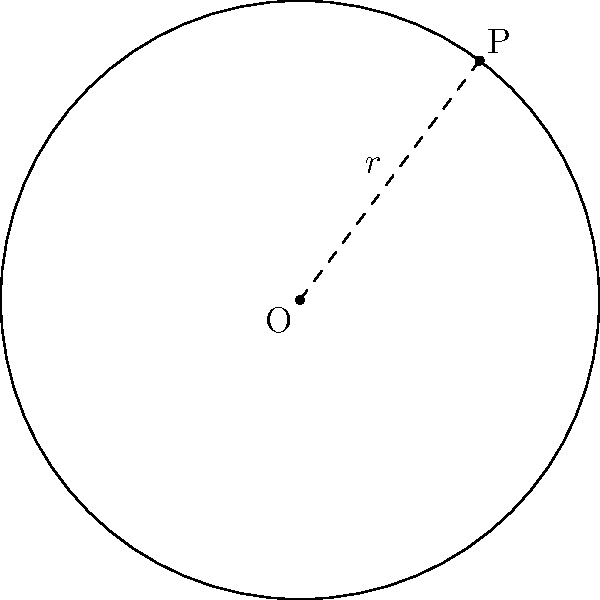In the Cartesian plane, a circle has its center at the origin O(0,0) and passes through the point P(3,4). What is the equation of this circle? Express your answer in standard form: $$(x-h)^2 + (y-k)^2 = r^2$$ To find the equation of the circle, we need to determine its radius and use the standard form of a circle equation.

Step 1: Calculate the radius
The radius is the distance from the center O(0,0) to the point P(3,4). We can use the distance formula:

$r = \sqrt{(x_2-x_1)^2 + (y_2-y_1)^2}$
$r = \sqrt{(3-0)^2 + (4-0)^2}$
$r = \sqrt{9 + 16} = \sqrt{25} = 5$

Step 2: Use the standard form of a circle equation
The standard form is $(x-h)^2 + (y-k)^2 = r^2$, where (h,k) is the center of the circle.

Since the center is at the origin (0,0), h=0 and k=0.
Substituting these values and the radius we found:

$(x-0)^2 + (y-0)^2 = 5^2$

Step 3: Simplify
$x^2 + y^2 = 25$

This is the equation of the circle in standard form.
Answer: $x^2 + y^2 = 25$ 